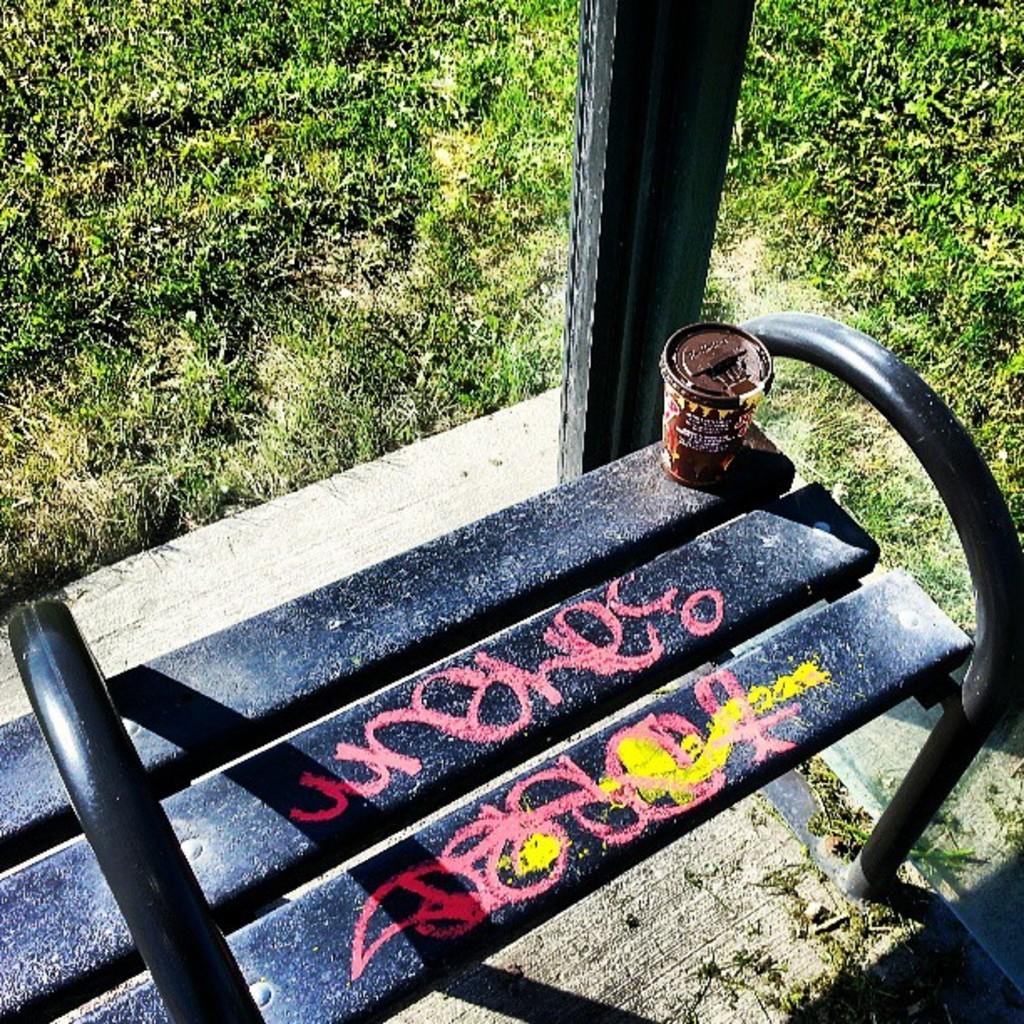Can you describe this image briefly? In this image I can see grass, a black colour bench and on it I can see a brown colour glass and here I can see pink colour painting. 